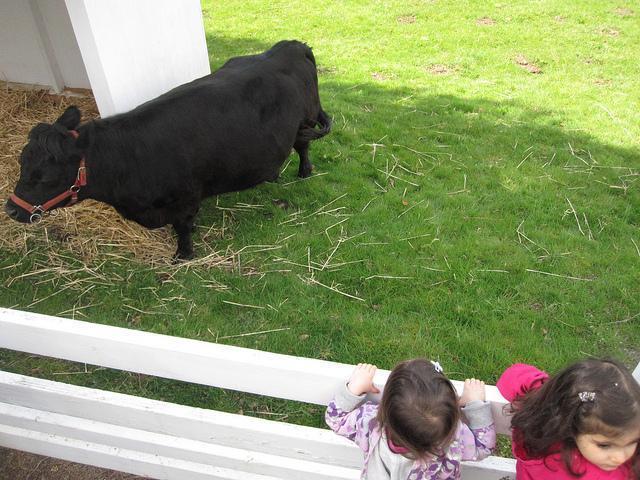How many cows are there?
Give a very brief answer. 1. How many child are in view?
Give a very brief answer. 2. How many cows are in the picture?
Give a very brief answer. 1. How many people are visible?
Give a very brief answer. 2. 